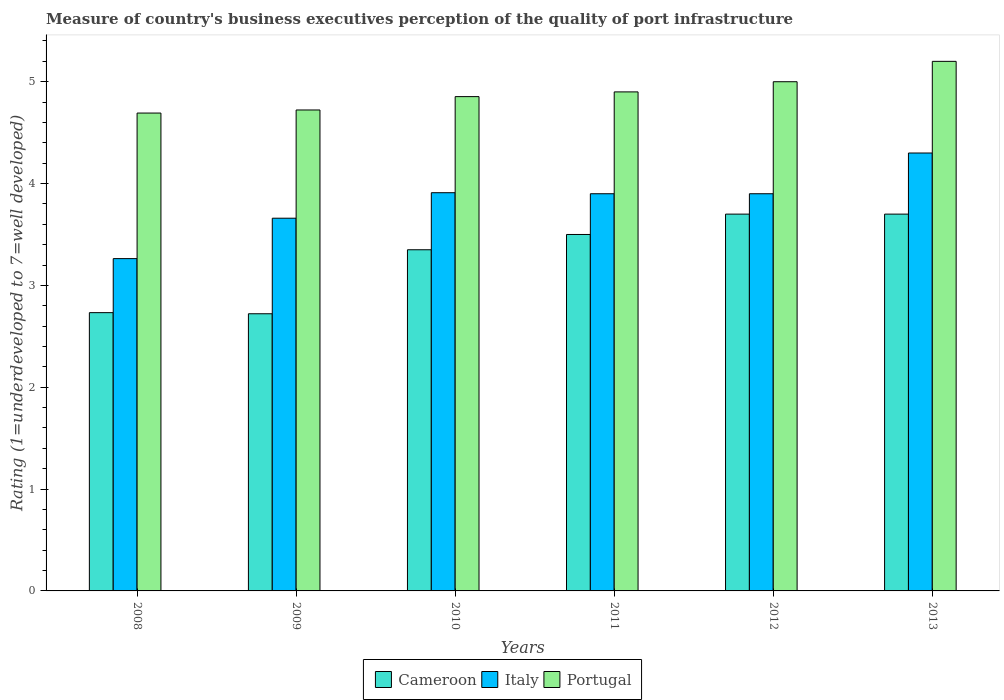How many groups of bars are there?
Your response must be concise. 6. Are the number of bars on each tick of the X-axis equal?
Give a very brief answer. Yes. How many bars are there on the 6th tick from the left?
Provide a succinct answer. 3. How many bars are there on the 3rd tick from the right?
Give a very brief answer. 3. What is the label of the 1st group of bars from the left?
Provide a short and direct response. 2008. In how many cases, is the number of bars for a given year not equal to the number of legend labels?
Keep it short and to the point. 0. Across all years, what is the maximum ratings of the quality of port infrastructure in Italy?
Your answer should be compact. 4.3. Across all years, what is the minimum ratings of the quality of port infrastructure in Cameroon?
Your answer should be very brief. 2.72. In which year was the ratings of the quality of port infrastructure in Portugal maximum?
Give a very brief answer. 2013. In which year was the ratings of the quality of port infrastructure in Portugal minimum?
Your answer should be very brief. 2008. What is the total ratings of the quality of port infrastructure in Cameroon in the graph?
Ensure brevity in your answer.  19.7. What is the difference between the ratings of the quality of port infrastructure in Portugal in 2009 and that in 2011?
Provide a short and direct response. -0.18. What is the difference between the ratings of the quality of port infrastructure in Portugal in 2008 and the ratings of the quality of port infrastructure in Cameroon in 2009?
Make the answer very short. 1.97. What is the average ratings of the quality of port infrastructure in Cameroon per year?
Provide a short and direct response. 3.28. In the year 2010, what is the difference between the ratings of the quality of port infrastructure in Italy and ratings of the quality of port infrastructure in Cameroon?
Provide a short and direct response. 0.56. In how many years, is the ratings of the quality of port infrastructure in Portugal greater than 3?
Offer a terse response. 6. What is the ratio of the ratings of the quality of port infrastructure in Portugal in 2011 to that in 2012?
Provide a short and direct response. 0.98. Is the ratings of the quality of port infrastructure in Italy in 2011 less than that in 2013?
Your response must be concise. Yes. What is the difference between the highest and the second highest ratings of the quality of port infrastructure in Italy?
Offer a terse response. 0.39. What is the difference between the highest and the lowest ratings of the quality of port infrastructure in Cameroon?
Make the answer very short. 0.98. In how many years, is the ratings of the quality of port infrastructure in Cameroon greater than the average ratings of the quality of port infrastructure in Cameroon taken over all years?
Keep it short and to the point. 4. Is it the case that in every year, the sum of the ratings of the quality of port infrastructure in Italy and ratings of the quality of port infrastructure in Cameroon is greater than the ratings of the quality of port infrastructure in Portugal?
Offer a terse response. Yes. How many years are there in the graph?
Your answer should be very brief. 6. What is the difference between two consecutive major ticks on the Y-axis?
Offer a very short reply. 1. Are the values on the major ticks of Y-axis written in scientific E-notation?
Your answer should be very brief. No. Does the graph contain any zero values?
Offer a terse response. No. Does the graph contain grids?
Your answer should be compact. No. Where does the legend appear in the graph?
Your answer should be very brief. Bottom center. What is the title of the graph?
Offer a terse response. Measure of country's business executives perception of the quality of port infrastructure. Does "Grenada" appear as one of the legend labels in the graph?
Your response must be concise. No. What is the label or title of the X-axis?
Offer a very short reply. Years. What is the label or title of the Y-axis?
Provide a succinct answer. Rating (1=underdeveloped to 7=well developed). What is the Rating (1=underdeveloped to 7=well developed) of Cameroon in 2008?
Your answer should be compact. 2.73. What is the Rating (1=underdeveloped to 7=well developed) of Italy in 2008?
Keep it short and to the point. 3.26. What is the Rating (1=underdeveloped to 7=well developed) of Portugal in 2008?
Provide a succinct answer. 4.69. What is the Rating (1=underdeveloped to 7=well developed) in Cameroon in 2009?
Give a very brief answer. 2.72. What is the Rating (1=underdeveloped to 7=well developed) of Italy in 2009?
Make the answer very short. 3.66. What is the Rating (1=underdeveloped to 7=well developed) of Portugal in 2009?
Your answer should be very brief. 4.72. What is the Rating (1=underdeveloped to 7=well developed) in Cameroon in 2010?
Your response must be concise. 3.35. What is the Rating (1=underdeveloped to 7=well developed) of Italy in 2010?
Your response must be concise. 3.91. What is the Rating (1=underdeveloped to 7=well developed) in Portugal in 2010?
Your response must be concise. 4.85. What is the Rating (1=underdeveloped to 7=well developed) in Italy in 2011?
Your response must be concise. 3.9. What is the Rating (1=underdeveloped to 7=well developed) in Portugal in 2011?
Give a very brief answer. 4.9. What is the Rating (1=underdeveloped to 7=well developed) in Italy in 2012?
Your answer should be compact. 3.9. What is the Rating (1=underdeveloped to 7=well developed) of Portugal in 2012?
Your answer should be very brief. 5. Across all years, what is the maximum Rating (1=underdeveloped to 7=well developed) of Cameroon?
Keep it short and to the point. 3.7. Across all years, what is the maximum Rating (1=underdeveloped to 7=well developed) of Portugal?
Ensure brevity in your answer.  5.2. Across all years, what is the minimum Rating (1=underdeveloped to 7=well developed) of Cameroon?
Ensure brevity in your answer.  2.72. Across all years, what is the minimum Rating (1=underdeveloped to 7=well developed) in Italy?
Provide a short and direct response. 3.26. Across all years, what is the minimum Rating (1=underdeveloped to 7=well developed) in Portugal?
Provide a short and direct response. 4.69. What is the total Rating (1=underdeveloped to 7=well developed) in Cameroon in the graph?
Give a very brief answer. 19.7. What is the total Rating (1=underdeveloped to 7=well developed) of Italy in the graph?
Your answer should be very brief. 22.93. What is the total Rating (1=underdeveloped to 7=well developed) of Portugal in the graph?
Make the answer very short. 29.37. What is the difference between the Rating (1=underdeveloped to 7=well developed) in Cameroon in 2008 and that in 2009?
Give a very brief answer. 0.01. What is the difference between the Rating (1=underdeveloped to 7=well developed) of Italy in 2008 and that in 2009?
Provide a short and direct response. -0.4. What is the difference between the Rating (1=underdeveloped to 7=well developed) of Portugal in 2008 and that in 2009?
Your answer should be compact. -0.03. What is the difference between the Rating (1=underdeveloped to 7=well developed) in Cameroon in 2008 and that in 2010?
Ensure brevity in your answer.  -0.62. What is the difference between the Rating (1=underdeveloped to 7=well developed) in Italy in 2008 and that in 2010?
Make the answer very short. -0.65. What is the difference between the Rating (1=underdeveloped to 7=well developed) in Portugal in 2008 and that in 2010?
Ensure brevity in your answer.  -0.16. What is the difference between the Rating (1=underdeveloped to 7=well developed) of Cameroon in 2008 and that in 2011?
Your answer should be compact. -0.77. What is the difference between the Rating (1=underdeveloped to 7=well developed) in Italy in 2008 and that in 2011?
Offer a terse response. -0.64. What is the difference between the Rating (1=underdeveloped to 7=well developed) in Portugal in 2008 and that in 2011?
Make the answer very short. -0.21. What is the difference between the Rating (1=underdeveloped to 7=well developed) of Cameroon in 2008 and that in 2012?
Offer a terse response. -0.97. What is the difference between the Rating (1=underdeveloped to 7=well developed) in Italy in 2008 and that in 2012?
Ensure brevity in your answer.  -0.64. What is the difference between the Rating (1=underdeveloped to 7=well developed) of Portugal in 2008 and that in 2012?
Ensure brevity in your answer.  -0.31. What is the difference between the Rating (1=underdeveloped to 7=well developed) in Cameroon in 2008 and that in 2013?
Your answer should be very brief. -0.97. What is the difference between the Rating (1=underdeveloped to 7=well developed) in Italy in 2008 and that in 2013?
Give a very brief answer. -1.04. What is the difference between the Rating (1=underdeveloped to 7=well developed) of Portugal in 2008 and that in 2013?
Make the answer very short. -0.51. What is the difference between the Rating (1=underdeveloped to 7=well developed) in Cameroon in 2009 and that in 2010?
Give a very brief answer. -0.63. What is the difference between the Rating (1=underdeveloped to 7=well developed) in Italy in 2009 and that in 2010?
Keep it short and to the point. -0.25. What is the difference between the Rating (1=underdeveloped to 7=well developed) of Portugal in 2009 and that in 2010?
Your answer should be compact. -0.13. What is the difference between the Rating (1=underdeveloped to 7=well developed) of Cameroon in 2009 and that in 2011?
Offer a terse response. -0.78. What is the difference between the Rating (1=underdeveloped to 7=well developed) of Italy in 2009 and that in 2011?
Keep it short and to the point. -0.24. What is the difference between the Rating (1=underdeveloped to 7=well developed) in Portugal in 2009 and that in 2011?
Give a very brief answer. -0.18. What is the difference between the Rating (1=underdeveloped to 7=well developed) of Cameroon in 2009 and that in 2012?
Provide a succinct answer. -0.98. What is the difference between the Rating (1=underdeveloped to 7=well developed) of Italy in 2009 and that in 2012?
Make the answer very short. -0.24. What is the difference between the Rating (1=underdeveloped to 7=well developed) of Portugal in 2009 and that in 2012?
Give a very brief answer. -0.28. What is the difference between the Rating (1=underdeveloped to 7=well developed) of Cameroon in 2009 and that in 2013?
Your answer should be very brief. -0.98. What is the difference between the Rating (1=underdeveloped to 7=well developed) of Italy in 2009 and that in 2013?
Give a very brief answer. -0.64. What is the difference between the Rating (1=underdeveloped to 7=well developed) of Portugal in 2009 and that in 2013?
Your answer should be very brief. -0.48. What is the difference between the Rating (1=underdeveloped to 7=well developed) in Italy in 2010 and that in 2011?
Your answer should be very brief. 0.01. What is the difference between the Rating (1=underdeveloped to 7=well developed) in Portugal in 2010 and that in 2011?
Your answer should be very brief. -0.05. What is the difference between the Rating (1=underdeveloped to 7=well developed) in Cameroon in 2010 and that in 2012?
Offer a terse response. -0.35. What is the difference between the Rating (1=underdeveloped to 7=well developed) in Italy in 2010 and that in 2012?
Offer a terse response. 0.01. What is the difference between the Rating (1=underdeveloped to 7=well developed) of Portugal in 2010 and that in 2012?
Provide a succinct answer. -0.15. What is the difference between the Rating (1=underdeveloped to 7=well developed) of Cameroon in 2010 and that in 2013?
Your answer should be compact. -0.35. What is the difference between the Rating (1=underdeveloped to 7=well developed) in Italy in 2010 and that in 2013?
Your response must be concise. -0.39. What is the difference between the Rating (1=underdeveloped to 7=well developed) of Portugal in 2010 and that in 2013?
Give a very brief answer. -0.35. What is the difference between the Rating (1=underdeveloped to 7=well developed) of Cameroon in 2011 and that in 2012?
Make the answer very short. -0.2. What is the difference between the Rating (1=underdeveloped to 7=well developed) in Italy in 2011 and that in 2012?
Make the answer very short. 0. What is the difference between the Rating (1=underdeveloped to 7=well developed) in Italy in 2012 and that in 2013?
Provide a succinct answer. -0.4. What is the difference between the Rating (1=underdeveloped to 7=well developed) in Portugal in 2012 and that in 2013?
Make the answer very short. -0.2. What is the difference between the Rating (1=underdeveloped to 7=well developed) in Cameroon in 2008 and the Rating (1=underdeveloped to 7=well developed) in Italy in 2009?
Make the answer very short. -0.93. What is the difference between the Rating (1=underdeveloped to 7=well developed) of Cameroon in 2008 and the Rating (1=underdeveloped to 7=well developed) of Portugal in 2009?
Offer a very short reply. -1.99. What is the difference between the Rating (1=underdeveloped to 7=well developed) in Italy in 2008 and the Rating (1=underdeveloped to 7=well developed) in Portugal in 2009?
Provide a succinct answer. -1.46. What is the difference between the Rating (1=underdeveloped to 7=well developed) in Cameroon in 2008 and the Rating (1=underdeveloped to 7=well developed) in Italy in 2010?
Offer a very short reply. -1.18. What is the difference between the Rating (1=underdeveloped to 7=well developed) in Cameroon in 2008 and the Rating (1=underdeveloped to 7=well developed) in Portugal in 2010?
Provide a short and direct response. -2.12. What is the difference between the Rating (1=underdeveloped to 7=well developed) of Italy in 2008 and the Rating (1=underdeveloped to 7=well developed) of Portugal in 2010?
Your answer should be very brief. -1.59. What is the difference between the Rating (1=underdeveloped to 7=well developed) in Cameroon in 2008 and the Rating (1=underdeveloped to 7=well developed) in Italy in 2011?
Keep it short and to the point. -1.17. What is the difference between the Rating (1=underdeveloped to 7=well developed) of Cameroon in 2008 and the Rating (1=underdeveloped to 7=well developed) of Portugal in 2011?
Keep it short and to the point. -2.17. What is the difference between the Rating (1=underdeveloped to 7=well developed) of Italy in 2008 and the Rating (1=underdeveloped to 7=well developed) of Portugal in 2011?
Make the answer very short. -1.64. What is the difference between the Rating (1=underdeveloped to 7=well developed) of Cameroon in 2008 and the Rating (1=underdeveloped to 7=well developed) of Italy in 2012?
Provide a short and direct response. -1.17. What is the difference between the Rating (1=underdeveloped to 7=well developed) of Cameroon in 2008 and the Rating (1=underdeveloped to 7=well developed) of Portugal in 2012?
Provide a short and direct response. -2.27. What is the difference between the Rating (1=underdeveloped to 7=well developed) in Italy in 2008 and the Rating (1=underdeveloped to 7=well developed) in Portugal in 2012?
Give a very brief answer. -1.74. What is the difference between the Rating (1=underdeveloped to 7=well developed) of Cameroon in 2008 and the Rating (1=underdeveloped to 7=well developed) of Italy in 2013?
Make the answer very short. -1.57. What is the difference between the Rating (1=underdeveloped to 7=well developed) of Cameroon in 2008 and the Rating (1=underdeveloped to 7=well developed) of Portugal in 2013?
Your answer should be compact. -2.47. What is the difference between the Rating (1=underdeveloped to 7=well developed) in Italy in 2008 and the Rating (1=underdeveloped to 7=well developed) in Portugal in 2013?
Provide a succinct answer. -1.94. What is the difference between the Rating (1=underdeveloped to 7=well developed) of Cameroon in 2009 and the Rating (1=underdeveloped to 7=well developed) of Italy in 2010?
Provide a succinct answer. -1.19. What is the difference between the Rating (1=underdeveloped to 7=well developed) of Cameroon in 2009 and the Rating (1=underdeveloped to 7=well developed) of Portugal in 2010?
Your answer should be very brief. -2.13. What is the difference between the Rating (1=underdeveloped to 7=well developed) of Italy in 2009 and the Rating (1=underdeveloped to 7=well developed) of Portugal in 2010?
Your answer should be compact. -1.19. What is the difference between the Rating (1=underdeveloped to 7=well developed) in Cameroon in 2009 and the Rating (1=underdeveloped to 7=well developed) in Italy in 2011?
Offer a terse response. -1.18. What is the difference between the Rating (1=underdeveloped to 7=well developed) in Cameroon in 2009 and the Rating (1=underdeveloped to 7=well developed) in Portugal in 2011?
Ensure brevity in your answer.  -2.18. What is the difference between the Rating (1=underdeveloped to 7=well developed) in Italy in 2009 and the Rating (1=underdeveloped to 7=well developed) in Portugal in 2011?
Make the answer very short. -1.24. What is the difference between the Rating (1=underdeveloped to 7=well developed) in Cameroon in 2009 and the Rating (1=underdeveloped to 7=well developed) in Italy in 2012?
Provide a short and direct response. -1.18. What is the difference between the Rating (1=underdeveloped to 7=well developed) of Cameroon in 2009 and the Rating (1=underdeveloped to 7=well developed) of Portugal in 2012?
Your answer should be compact. -2.28. What is the difference between the Rating (1=underdeveloped to 7=well developed) in Italy in 2009 and the Rating (1=underdeveloped to 7=well developed) in Portugal in 2012?
Your response must be concise. -1.34. What is the difference between the Rating (1=underdeveloped to 7=well developed) in Cameroon in 2009 and the Rating (1=underdeveloped to 7=well developed) in Italy in 2013?
Provide a short and direct response. -1.58. What is the difference between the Rating (1=underdeveloped to 7=well developed) in Cameroon in 2009 and the Rating (1=underdeveloped to 7=well developed) in Portugal in 2013?
Provide a short and direct response. -2.48. What is the difference between the Rating (1=underdeveloped to 7=well developed) in Italy in 2009 and the Rating (1=underdeveloped to 7=well developed) in Portugal in 2013?
Offer a very short reply. -1.54. What is the difference between the Rating (1=underdeveloped to 7=well developed) in Cameroon in 2010 and the Rating (1=underdeveloped to 7=well developed) in Italy in 2011?
Provide a short and direct response. -0.55. What is the difference between the Rating (1=underdeveloped to 7=well developed) of Cameroon in 2010 and the Rating (1=underdeveloped to 7=well developed) of Portugal in 2011?
Your response must be concise. -1.55. What is the difference between the Rating (1=underdeveloped to 7=well developed) of Italy in 2010 and the Rating (1=underdeveloped to 7=well developed) of Portugal in 2011?
Your answer should be very brief. -0.99. What is the difference between the Rating (1=underdeveloped to 7=well developed) in Cameroon in 2010 and the Rating (1=underdeveloped to 7=well developed) in Italy in 2012?
Offer a terse response. -0.55. What is the difference between the Rating (1=underdeveloped to 7=well developed) in Cameroon in 2010 and the Rating (1=underdeveloped to 7=well developed) in Portugal in 2012?
Provide a succinct answer. -1.65. What is the difference between the Rating (1=underdeveloped to 7=well developed) in Italy in 2010 and the Rating (1=underdeveloped to 7=well developed) in Portugal in 2012?
Keep it short and to the point. -1.09. What is the difference between the Rating (1=underdeveloped to 7=well developed) of Cameroon in 2010 and the Rating (1=underdeveloped to 7=well developed) of Italy in 2013?
Your answer should be very brief. -0.95. What is the difference between the Rating (1=underdeveloped to 7=well developed) of Cameroon in 2010 and the Rating (1=underdeveloped to 7=well developed) of Portugal in 2013?
Make the answer very short. -1.85. What is the difference between the Rating (1=underdeveloped to 7=well developed) in Italy in 2010 and the Rating (1=underdeveloped to 7=well developed) in Portugal in 2013?
Give a very brief answer. -1.29. What is the difference between the Rating (1=underdeveloped to 7=well developed) of Cameroon in 2011 and the Rating (1=underdeveloped to 7=well developed) of Portugal in 2012?
Keep it short and to the point. -1.5. What is the difference between the Rating (1=underdeveloped to 7=well developed) in Cameroon in 2011 and the Rating (1=underdeveloped to 7=well developed) in Portugal in 2013?
Offer a very short reply. -1.7. What is the difference between the Rating (1=underdeveloped to 7=well developed) in Italy in 2011 and the Rating (1=underdeveloped to 7=well developed) in Portugal in 2013?
Your response must be concise. -1.3. What is the difference between the Rating (1=underdeveloped to 7=well developed) of Cameroon in 2012 and the Rating (1=underdeveloped to 7=well developed) of Portugal in 2013?
Offer a very short reply. -1.5. What is the difference between the Rating (1=underdeveloped to 7=well developed) in Italy in 2012 and the Rating (1=underdeveloped to 7=well developed) in Portugal in 2013?
Ensure brevity in your answer.  -1.3. What is the average Rating (1=underdeveloped to 7=well developed) of Cameroon per year?
Your answer should be compact. 3.28. What is the average Rating (1=underdeveloped to 7=well developed) of Italy per year?
Keep it short and to the point. 3.82. What is the average Rating (1=underdeveloped to 7=well developed) in Portugal per year?
Your answer should be compact. 4.89. In the year 2008, what is the difference between the Rating (1=underdeveloped to 7=well developed) in Cameroon and Rating (1=underdeveloped to 7=well developed) in Italy?
Keep it short and to the point. -0.53. In the year 2008, what is the difference between the Rating (1=underdeveloped to 7=well developed) in Cameroon and Rating (1=underdeveloped to 7=well developed) in Portugal?
Your answer should be very brief. -1.96. In the year 2008, what is the difference between the Rating (1=underdeveloped to 7=well developed) in Italy and Rating (1=underdeveloped to 7=well developed) in Portugal?
Keep it short and to the point. -1.43. In the year 2009, what is the difference between the Rating (1=underdeveloped to 7=well developed) of Cameroon and Rating (1=underdeveloped to 7=well developed) of Italy?
Keep it short and to the point. -0.94. In the year 2009, what is the difference between the Rating (1=underdeveloped to 7=well developed) in Cameroon and Rating (1=underdeveloped to 7=well developed) in Portugal?
Your response must be concise. -2. In the year 2009, what is the difference between the Rating (1=underdeveloped to 7=well developed) in Italy and Rating (1=underdeveloped to 7=well developed) in Portugal?
Ensure brevity in your answer.  -1.06. In the year 2010, what is the difference between the Rating (1=underdeveloped to 7=well developed) in Cameroon and Rating (1=underdeveloped to 7=well developed) in Italy?
Offer a very short reply. -0.56. In the year 2010, what is the difference between the Rating (1=underdeveloped to 7=well developed) in Cameroon and Rating (1=underdeveloped to 7=well developed) in Portugal?
Ensure brevity in your answer.  -1.5. In the year 2010, what is the difference between the Rating (1=underdeveloped to 7=well developed) in Italy and Rating (1=underdeveloped to 7=well developed) in Portugal?
Your response must be concise. -0.94. In the year 2011, what is the difference between the Rating (1=underdeveloped to 7=well developed) in Cameroon and Rating (1=underdeveloped to 7=well developed) in Italy?
Your answer should be compact. -0.4. In the year 2013, what is the difference between the Rating (1=underdeveloped to 7=well developed) of Cameroon and Rating (1=underdeveloped to 7=well developed) of Portugal?
Keep it short and to the point. -1.5. In the year 2013, what is the difference between the Rating (1=underdeveloped to 7=well developed) of Italy and Rating (1=underdeveloped to 7=well developed) of Portugal?
Your response must be concise. -0.9. What is the ratio of the Rating (1=underdeveloped to 7=well developed) in Cameroon in 2008 to that in 2009?
Keep it short and to the point. 1. What is the ratio of the Rating (1=underdeveloped to 7=well developed) of Italy in 2008 to that in 2009?
Keep it short and to the point. 0.89. What is the ratio of the Rating (1=underdeveloped to 7=well developed) of Cameroon in 2008 to that in 2010?
Your response must be concise. 0.82. What is the ratio of the Rating (1=underdeveloped to 7=well developed) in Italy in 2008 to that in 2010?
Keep it short and to the point. 0.83. What is the ratio of the Rating (1=underdeveloped to 7=well developed) of Portugal in 2008 to that in 2010?
Give a very brief answer. 0.97. What is the ratio of the Rating (1=underdeveloped to 7=well developed) in Cameroon in 2008 to that in 2011?
Offer a very short reply. 0.78. What is the ratio of the Rating (1=underdeveloped to 7=well developed) in Italy in 2008 to that in 2011?
Ensure brevity in your answer.  0.84. What is the ratio of the Rating (1=underdeveloped to 7=well developed) in Portugal in 2008 to that in 2011?
Ensure brevity in your answer.  0.96. What is the ratio of the Rating (1=underdeveloped to 7=well developed) of Cameroon in 2008 to that in 2012?
Make the answer very short. 0.74. What is the ratio of the Rating (1=underdeveloped to 7=well developed) of Italy in 2008 to that in 2012?
Offer a very short reply. 0.84. What is the ratio of the Rating (1=underdeveloped to 7=well developed) in Portugal in 2008 to that in 2012?
Offer a very short reply. 0.94. What is the ratio of the Rating (1=underdeveloped to 7=well developed) of Cameroon in 2008 to that in 2013?
Ensure brevity in your answer.  0.74. What is the ratio of the Rating (1=underdeveloped to 7=well developed) in Italy in 2008 to that in 2013?
Your answer should be compact. 0.76. What is the ratio of the Rating (1=underdeveloped to 7=well developed) in Portugal in 2008 to that in 2013?
Your answer should be compact. 0.9. What is the ratio of the Rating (1=underdeveloped to 7=well developed) in Cameroon in 2009 to that in 2010?
Provide a short and direct response. 0.81. What is the ratio of the Rating (1=underdeveloped to 7=well developed) in Italy in 2009 to that in 2010?
Make the answer very short. 0.94. What is the ratio of the Rating (1=underdeveloped to 7=well developed) of Portugal in 2009 to that in 2010?
Provide a short and direct response. 0.97. What is the ratio of the Rating (1=underdeveloped to 7=well developed) of Cameroon in 2009 to that in 2011?
Your answer should be very brief. 0.78. What is the ratio of the Rating (1=underdeveloped to 7=well developed) in Italy in 2009 to that in 2011?
Offer a terse response. 0.94. What is the ratio of the Rating (1=underdeveloped to 7=well developed) of Portugal in 2009 to that in 2011?
Give a very brief answer. 0.96. What is the ratio of the Rating (1=underdeveloped to 7=well developed) of Cameroon in 2009 to that in 2012?
Keep it short and to the point. 0.74. What is the ratio of the Rating (1=underdeveloped to 7=well developed) of Italy in 2009 to that in 2012?
Give a very brief answer. 0.94. What is the ratio of the Rating (1=underdeveloped to 7=well developed) in Portugal in 2009 to that in 2012?
Offer a terse response. 0.94. What is the ratio of the Rating (1=underdeveloped to 7=well developed) in Cameroon in 2009 to that in 2013?
Make the answer very short. 0.74. What is the ratio of the Rating (1=underdeveloped to 7=well developed) in Italy in 2009 to that in 2013?
Provide a short and direct response. 0.85. What is the ratio of the Rating (1=underdeveloped to 7=well developed) of Portugal in 2009 to that in 2013?
Provide a short and direct response. 0.91. What is the ratio of the Rating (1=underdeveloped to 7=well developed) in Cameroon in 2010 to that in 2011?
Offer a very short reply. 0.96. What is the ratio of the Rating (1=underdeveloped to 7=well developed) in Portugal in 2010 to that in 2011?
Offer a terse response. 0.99. What is the ratio of the Rating (1=underdeveloped to 7=well developed) of Cameroon in 2010 to that in 2012?
Provide a short and direct response. 0.91. What is the ratio of the Rating (1=underdeveloped to 7=well developed) of Portugal in 2010 to that in 2012?
Ensure brevity in your answer.  0.97. What is the ratio of the Rating (1=underdeveloped to 7=well developed) of Cameroon in 2010 to that in 2013?
Your answer should be compact. 0.91. What is the ratio of the Rating (1=underdeveloped to 7=well developed) of Italy in 2010 to that in 2013?
Ensure brevity in your answer.  0.91. What is the ratio of the Rating (1=underdeveloped to 7=well developed) in Portugal in 2010 to that in 2013?
Your answer should be very brief. 0.93. What is the ratio of the Rating (1=underdeveloped to 7=well developed) in Cameroon in 2011 to that in 2012?
Your response must be concise. 0.95. What is the ratio of the Rating (1=underdeveloped to 7=well developed) of Portugal in 2011 to that in 2012?
Make the answer very short. 0.98. What is the ratio of the Rating (1=underdeveloped to 7=well developed) in Cameroon in 2011 to that in 2013?
Provide a short and direct response. 0.95. What is the ratio of the Rating (1=underdeveloped to 7=well developed) in Italy in 2011 to that in 2013?
Offer a terse response. 0.91. What is the ratio of the Rating (1=underdeveloped to 7=well developed) in Portugal in 2011 to that in 2013?
Offer a very short reply. 0.94. What is the ratio of the Rating (1=underdeveloped to 7=well developed) in Cameroon in 2012 to that in 2013?
Give a very brief answer. 1. What is the ratio of the Rating (1=underdeveloped to 7=well developed) in Italy in 2012 to that in 2013?
Keep it short and to the point. 0.91. What is the ratio of the Rating (1=underdeveloped to 7=well developed) of Portugal in 2012 to that in 2013?
Offer a terse response. 0.96. What is the difference between the highest and the second highest Rating (1=underdeveloped to 7=well developed) in Italy?
Offer a terse response. 0.39. What is the difference between the highest and the lowest Rating (1=underdeveloped to 7=well developed) in Cameroon?
Offer a terse response. 0.98. What is the difference between the highest and the lowest Rating (1=underdeveloped to 7=well developed) in Italy?
Provide a short and direct response. 1.04. What is the difference between the highest and the lowest Rating (1=underdeveloped to 7=well developed) in Portugal?
Your response must be concise. 0.51. 